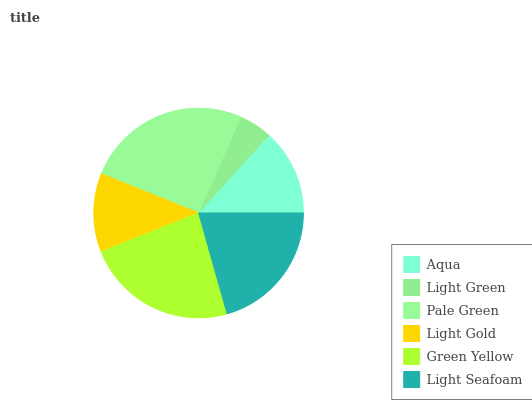Is Light Green the minimum?
Answer yes or no. Yes. Is Pale Green the maximum?
Answer yes or no. Yes. Is Pale Green the minimum?
Answer yes or no. No. Is Light Green the maximum?
Answer yes or no. No. Is Pale Green greater than Light Green?
Answer yes or no. Yes. Is Light Green less than Pale Green?
Answer yes or no. Yes. Is Light Green greater than Pale Green?
Answer yes or no. No. Is Pale Green less than Light Green?
Answer yes or no. No. Is Light Seafoam the high median?
Answer yes or no. Yes. Is Aqua the low median?
Answer yes or no. Yes. Is Light Gold the high median?
Answer yes or no. No. Is Light Gold the low median?
Answer yes or no. No. 